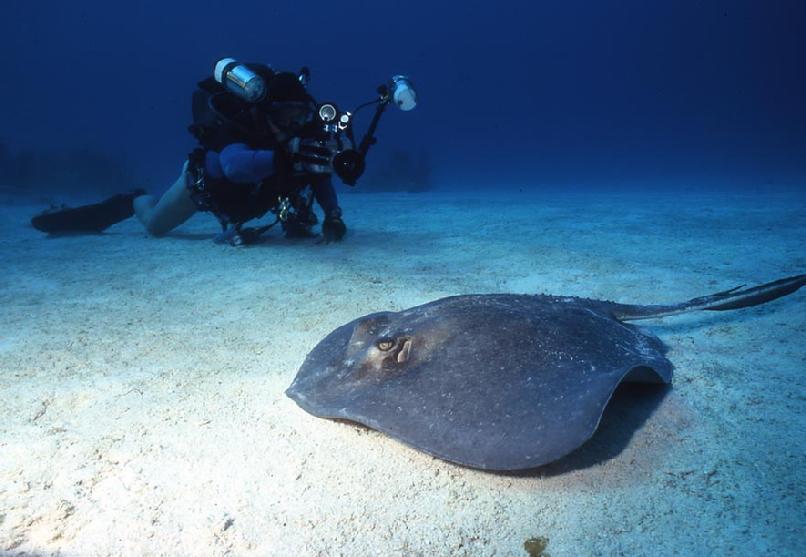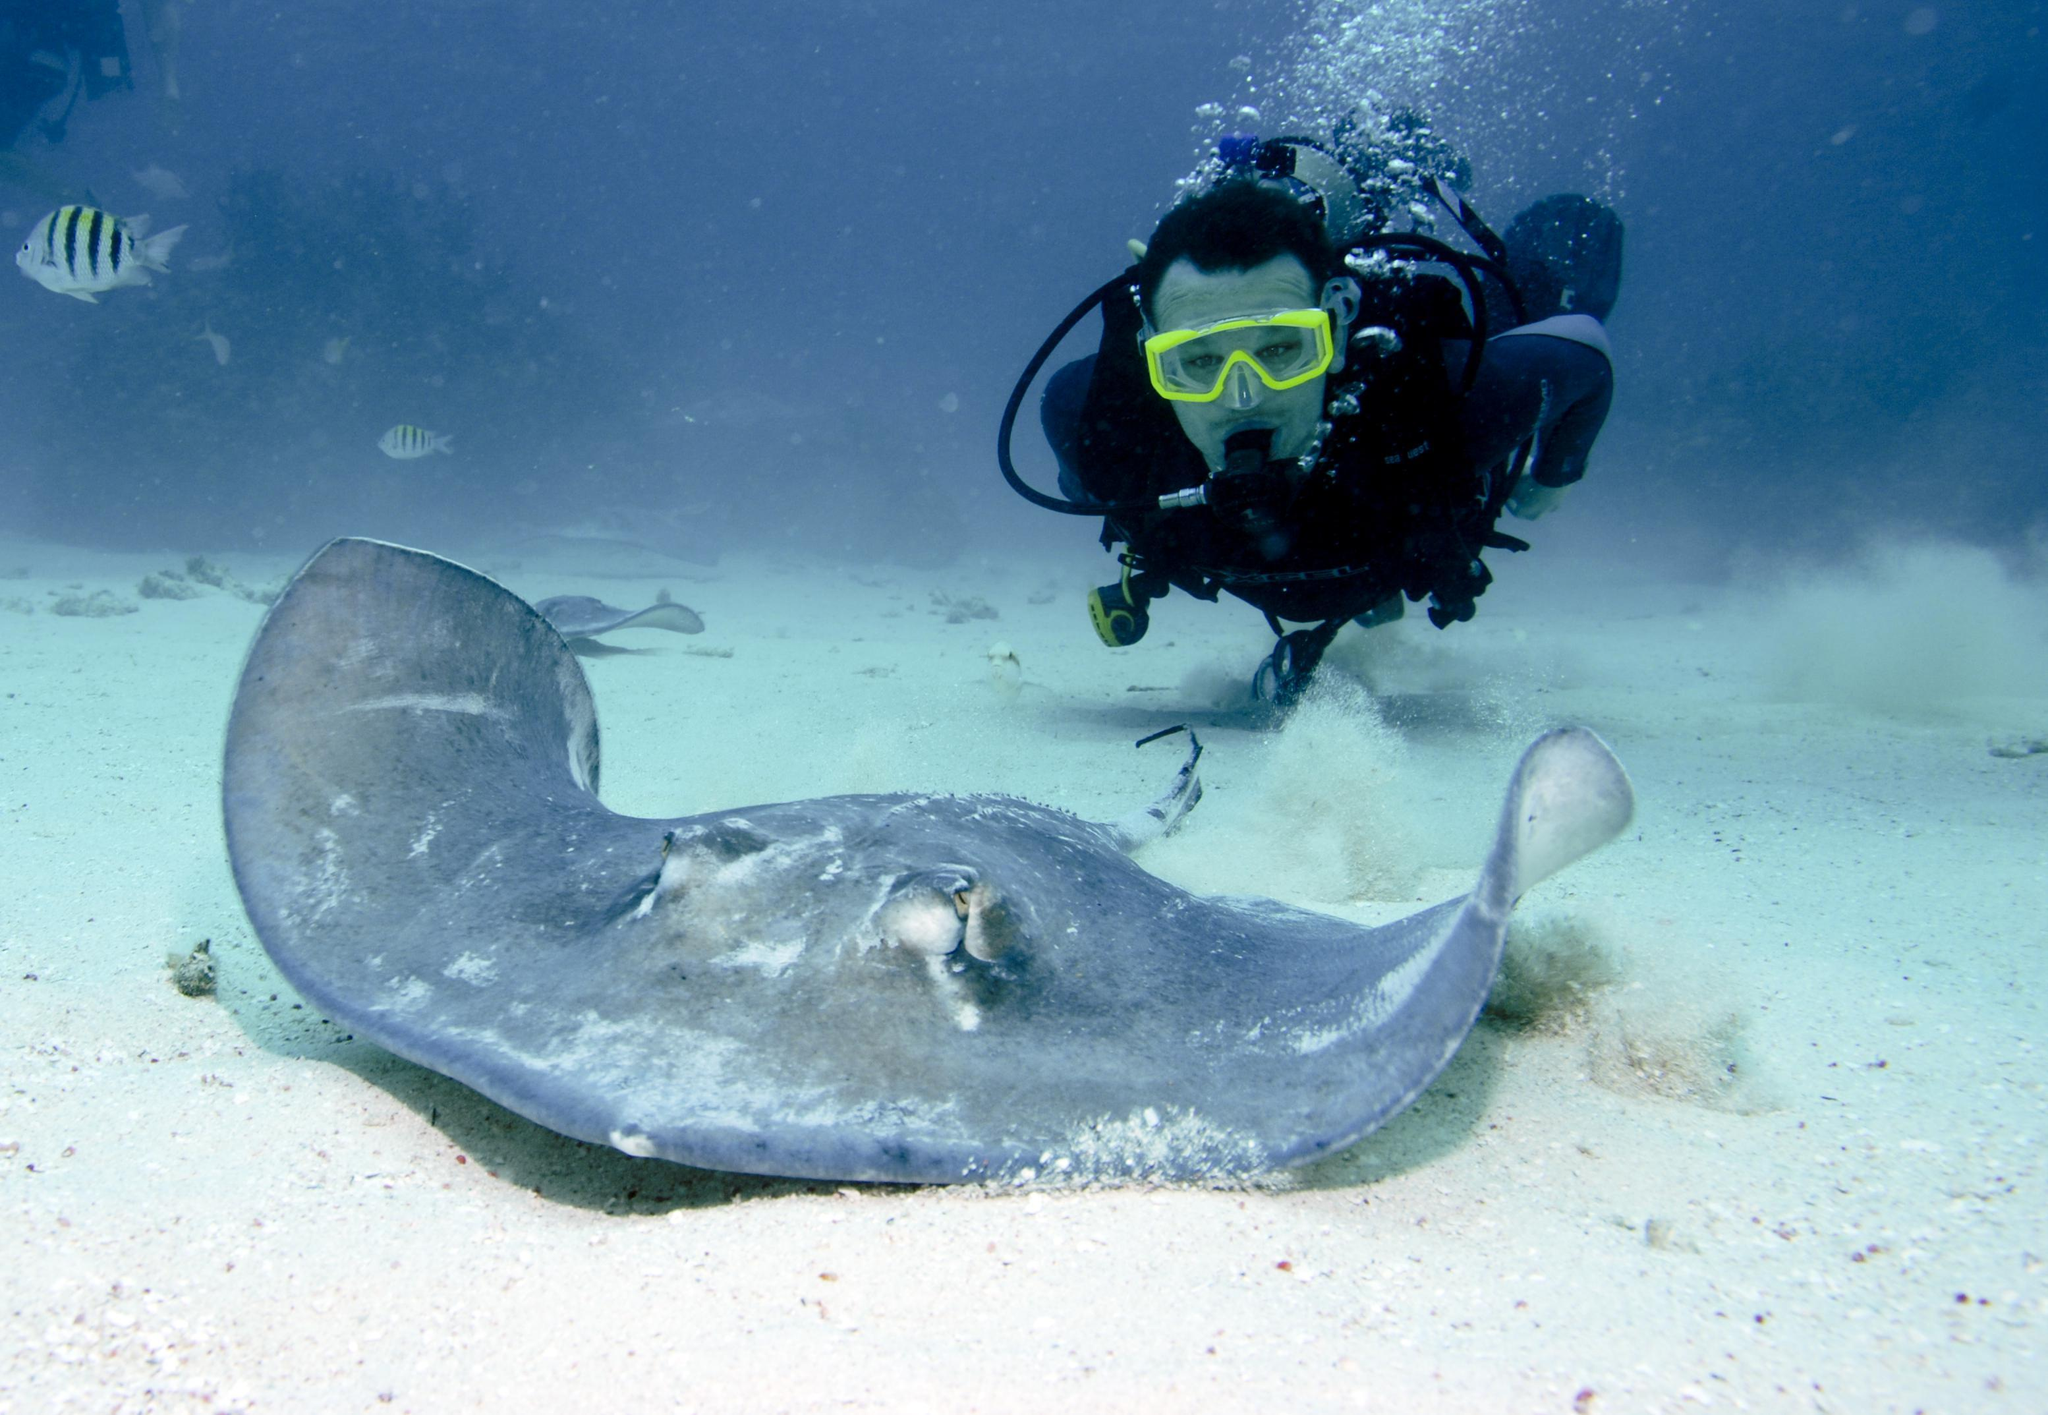The first image is the image on the left, the second image is the image on the right. Given the left and right images, does the statement "There is at least one image of a sting ray over the sand that is in front of a diver who is swimming." hold true? Answer yes or no. Yes. The first image is the image on the left, the second image is the image on the right. Given the left and right images, does the statement "There are exactly two scuba divers." hold true? Answer yes or no. Yes. 